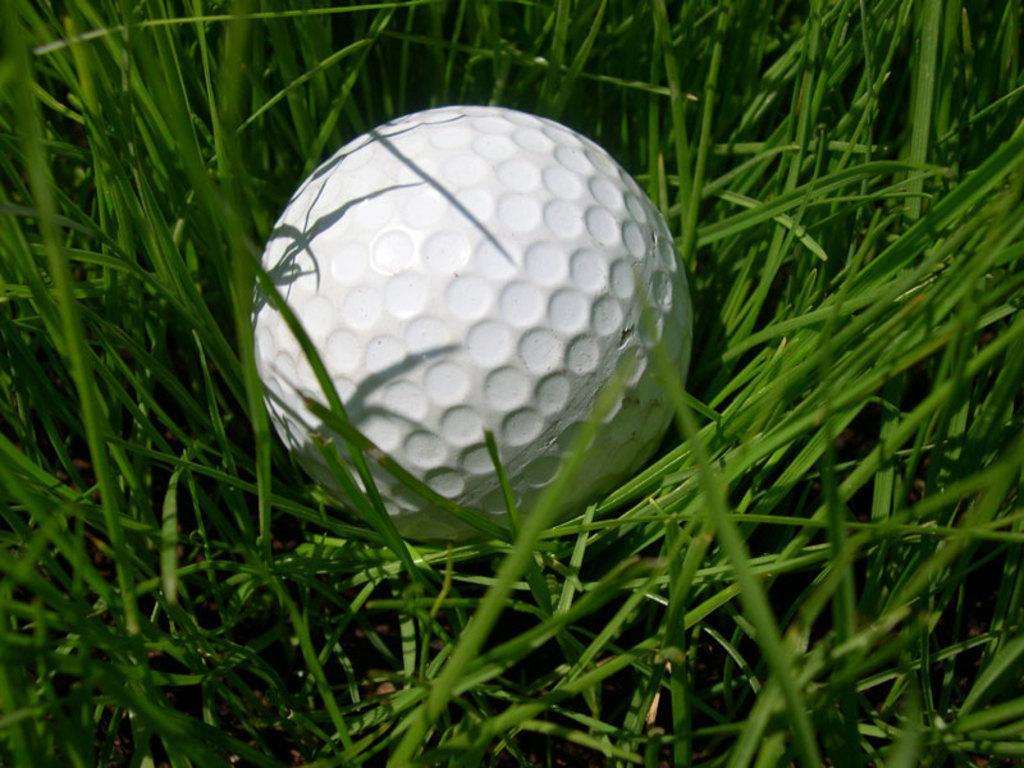Describe this image in one or two sentences. In this image I can see a white colour ball and green grass. 